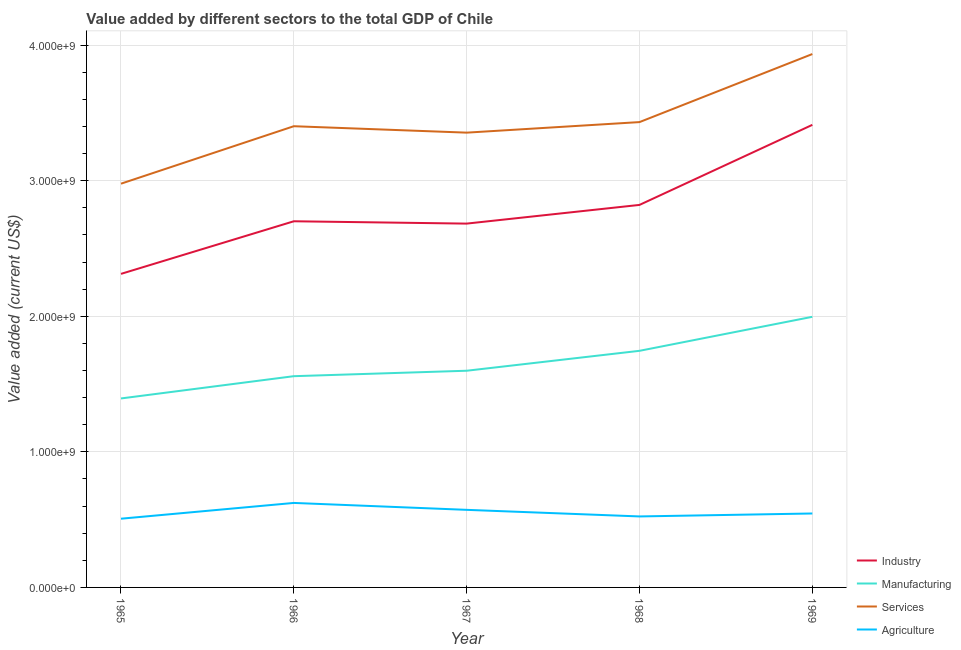What is the value added by agricultural sector in 1968?
Ensure brevity in your answer.  5.24e+08. Across all years, what is the maximum value added by agricultural sector?
Your answer should be compact. 6.23e+08. Across all years, what is the minimum value added by agricultural sector?
Offer a terse response. 5.07e+08. In which year was the value added by services sector maximum?
Offer a terse response. 1969. In which year was the value added by manufacturing sector minimum?
Provide a short and direct response. 1965. What is the total value added by manufacturing sector in the graph?
Provide a short and direct response. 8.29e+09. What is the difference between the value added by services sector in 1967 and that in 1969?
Your answer should be very brief. -5.80e+08. What is the difference between the value added by industrial sector in 1966 and the value added by agricultural sector in 1965?
Ensure brevity in your answer.  2.19e+09. What is the average value added by manufacturing sector per year?
Make the answer very short. 1.66e+09. In the year 1967, what is the difference between the value added by manufacturing sector and value added by agricultural sector?
Provide a short and direct response. 1.03e+09. What is the ratio of the value added by agricultural sector in 1968 to that in 1969?
Your answer should be very brief. 0.96. Is the difference between the value added by agricultural sector in 1965 and 1968 greater than the difference between the value added by industrial sector in 1965 and 1968?
Your response must be concise. Yes. What is the difference between the highest and the second highest value added by manufacturing sector?
Offer a very short reply. 2.51e+08. What is the difference between the highest and the lowest value added by services sector?
Provide a short and direct response. 9.56e+08. In how many years, is the value added by agricultural sector greater than the average value added by agricultural sector taken over all years?
Offer a terse response. 2. Is the sum of the value added by services sector in 1965 and 1967 greater than the maximum value added by agricultural sector across all years?
Give a very brief answer. Yes. Is it the case that in every year, the sum of the value added by industrial sector and value added by manufacturing sector is greater than the value added by services sector?
Your response must be concise. Yes. Does the value added by services sector monotonically increase over the years?
Offer a very short reply. No. How many lines are there?
Your answer should be very brief. 4. How many years are there in the graph?
Give a very brief answer. 5. Are the values on the major ticks of Y-axis written in scientific E-notation?
Your response must be concise. Yes. How are the legend labels stacked?
Give a very brief answer. Vertical. What is the title of the graph?
Ensure brevity in your answer.  Value added by different sectors to the total GDP of Chile. What is the label or title of the Y-axis?
Make the answer very short. Value added (current US$). What is the Value added (current US$) in Industry in 1965?
Your answer should be very brief. 2.31e+09. What is the Value added (current US$) in Manufacturing in 1965?
Offer a terse response. 1.39e+09. What is the Value added (current US$) of Services in 1965?
Provide a succinct answer. 2.98e+09. What is the Value added (current US$) in Agriculture in 1965?
Make the answer very short. 5.07e+08. What is the Value added (current US$) in Industry in 1966?
Offer a very short reply. 2.70e+09. What is the Value added (current US$) of Manufacturing in 1966?
Your answer should be very brief. 1.56e+09. What is the Value added (current US$) of Services in 1966?
Offer a very short reply. 3.40e+09. What is the Value added (current US$) in Agriculture in 1966?
Make the answer very short. 6.23e+08. What is the Value added (current US$) in Industry in 1967?
Make the answer very short. 2.68e+09. What is the Value added (current US$) of Manufacturing in 1967?
Your answer should be very brief. 1.60e+09. What is the Value added (current US$) in Services in 1967?
Keep it short and to the point. 3.35e+09. What is the Value added (current US$) in Agriculture in 1967?
Ensure brevity in your answer.  5.72e+08. What is the Value added (current US$) of Industry in 1968?
Your response must be concise. 2.82e+09. What is the Value added (current US$) of Manufacturing in 1968?
Ensure brevity in your answer.  1.75e+09. What is the Value added (current US$) of Services in 1968?
Your answer should be compact. 3.43e+09. What is the Value added (current US$) in Agriculture in 1968?
Offer a very short reply. 5.24e+08. What is the Value added (current US$) in Industry in 1969?
Ensure brevity in your answer.  3.41e+09. What is the Value added (current US$) of Manufacturing in 1969?
Your answer should be compact. 2.00e+09. What is the Value added (current US$) in Services in 1969?
Provide a short and direct response. 3.93e+09. What is the Value added (current US$) of Agriculture in 1969?
Provide a succinct answer. 5.45e+08. Across all years, what is the maximum Value added (current US$) of Industry?
Give a very brief answer. 3.41e+09. Across all years, what is the maximum Value added (current US$) in Manufacturing?
Offer a terse response. 2.00e+09. Across all years, what is the maximum Value added (current US$) in Services?
Make the answer very short. 3.93e+09. Across all years, what is the maximum Value added (current US$) in Agriculture?
Give a very brief answer. 6.23e+08. Across all years, what is the minimum Value added (current US$) in Industry?
Keep it short and to the point. 2.31e+09. Across all years, what is the minimum Value added (current US$) in Manufacturing?
Make the answer very short. 1.39e+09. Across all years, what is the minimum Value added (current US$) of Services?
Your answer should be compact. 2.98e+09. Across all years, what is the minimum Value added (current US$) of Agriculture?
Your answer should be very brief. 5.07e+08. What is the total Value added (current US$) in Industry in the graph?
Offer a terse response. 1.39e+1. What is the total Value added (current US$) in Manufacturing in the graph?
Your answer should be compact. 8.29e+09. What is the total Value added (current US$) in Services in the graph?
Make the answer very short. 1.71e+1. What is the total Value added (current US$) of Agriculture in the graph?
Keep it short and to the point. 2.77e+09. What is the difference between the Value added (current US$) in Industry in 1965 and that in 1966?
Make the answer very short. -3.88e+08. What is the difference between the Value added (current US$) of Manufacturing in 1965 and that in 1966?
Offer a very short reply. -1.64e+08. What is the difference between the Value added (current US$) of Services in 1965 and that in 1966?
Make the answer very short. -4.24e+08. What is the difference between the Value added (current US$) in Agriculture in 1965 and that in 1966?
Your answer should be compact. -1.16e+08. What is the difference between the Value added (current US$) in Industry in 1965 and that in 1967?
Your response must be concise. -3.71e+08. What is the difference between the Value added (current US$) in Manufacturing in 1965 and that in 1967?
Ensure brevity in your answer.  -2.04e+08. What is the difference between the Value added (current US$) in Services in 1965 and that in 1967?
Make the answer very short. -3.76e+08. What is the difference between the Value added (current US$) in Agriculture in 1965 and that in 1967?
Offer a terse response. -6.53e+07. What is the difference between the Value added (current US$) in Industry in 1965 and that in 1968?
Provide a succinct answer. -5.09e+08. What is the difference between the Value added (current US$) of Manufacturing in 1965 and that in 1968?
Your answer should be very brief. -3.51e+08. What is the difference between the Value added (current US$) of Services in 1965 and that in 1968?
Give a very brief answer. -4.54e+08. What is the difference between the Value added (current US$) in Agriculture in 1965 and that in 1968?
Provide a short and direct response. -1.67e+07. What is the difference between the Value added (current US$) in Industry in 1965 and that in 1969?
Ensure brevity in your answer.  -1.10e+09. What is the difference between the Value added (current US$) of Manufacturing in 1965 and that in 1969?
Provide a short and direct response. -6.02e+08. What is the difference between the Value added (current US$) of Services in 1965 and that in 1969?
Offer a very short reply. -9.56e+08. What is the difference between the Value added (current US$) of Agriculture in 1965 and that in 1969?
Your response must be concise. -3.85e+07. What is the difference between the Value added (current US$) of Industry in 1966 and that in 1967?
Offer a terse response. 1.72e+07. What is the difference between the Value added (current US$) in Manufacturing in 1966 and that in 1967?
Make the answer very short. -4.02e+07. What is the difference between the Value added (current US$) of Services in 1966 and that in 1967?
Ensure brevity in your answer.  4.74e+07. What is the difference between the Value added (current US$) in Agriculture in 1966 and that in 1967?
Give a very brief answer. 5.10e+07. What is the difference between the Value added (current US$) in Industry in 1966 and that in 1968?
Keep it short and to the point. -1.21e+08. What is the difference between the Value added (current US$) of Manufacturing in 1966 and that in 1968?
Provide a short and direct response. -1.87e+08. What is the difference between the Value added (current US$) of Services in 1966 and that in 1968?
Your response must be concise. -3.04e+07. What is the difference between the Value added (current US$) in Agriculture in 1966 and that in 1968?
Offer a terse response. 9.97e+07. What is the difference between the Value added (current US$) in Industry in 1966 and that in 1969?
Your answer should be very brief. -7.11e+08. What is the difference between the Value added (current US$) of Manufacturing in 1966 and that in 1969?
Your answer should be compact. -4.38e+08. What is the difference between the Value added (current US$) in Services in 1966 and that in 1969?
Your answer should be compact. -5.32e+08. What is the difference between the Value added (current US$) in Agriculture in 1966 and that in 1969?
Provide a succinct answer. 7.78e+07. What is the difference between the Value added (current US$) of Industry in 1967 and that in 1968?
Offer a terse response. -1.38e+08. What is the difference between the Value added (current US$) in Manufacturing in 1967 and that in 1968?
Keep it short and to the point. -1.47e+08. What is the difference between the Value added (current US$) in Services in 1967 and that in 1968?
Make the answer very short. -7.78e+07. What is the difference between the Value added (current US$) in Agriculture in 1967 and that in 1968?
Ensure brevity in your answer.  4.87e+07. What is the difference between the Value added (current US$) of Industry in 1967 and that in 1969?
Make the answer very short. -7.28e+08. What is the difference between the Value added (current US$) of Manufacturing in 1967 and that in 1969?
Offer a terse response. -3.98e+08. What is the difference between the Value added (current US$) in Services in 1967 and that in 1969?
Ensure brevity in your answer.  -5.80e+08. What is the difference between the Value added (current US$) of Agriculture in 1967 and that in 1969?
Offer a very short reply. 2.68e+07. What is the difference between the Value added (current US$) in Industry in 1968 and that in 1969?
Your answer should be very brief. -5.90e+08. What is the difference between the Value added (current US$) in Manufacturing in 1968 and that in 1969?
Provide a succinct answer. -2.51e+08. What is the difference between the Value added (current US$) in Services in 1968 and that in 1969?
Your answer should be compact. -5.02e+08. What is the difference between the Value added (current US$) in Agriculture in 1968 and that in 1969?
Your answer should be very brief. -2.19e+07. What is the difference between the Value added (current US$) in Industry in 1965 and the Value added (current US$) in Manufacturing in 1966?
Make the answer very short. 7.55e+08. What is the difference between the Value added (current US$) of Industry in 1965 and the Value added (current US$) of Services in 1966?
Make the answer very short. -1.09e+09. What is the difference between the Value added (current US$) of Industry in 1965 and the Value added (current US$) of Agriculture in 1966?
Ensure brevity in your answer.  1.69e+09. What is the difference between the Value added (current US$) of Manufacturing in 1965 and the Value added (current US$) of Services in 1966?
Offer a very short reply. -2.01e+09. What is the difference between the Value added (current US$) of Manufacturing in 1965 and the Value added (current US$) of Agriculture in 1966?
Offer a terse response. 7.71e+08. What is the difference between the Value added (current US$) of Services in 1965 and the Value added (current US$) of Agriculture in 1966?
Keep it short and to the point. 2.35e+09. What is the difference between the Value added (current US$) of Industry in 1965 and the Value added (current US$) of Manufacturing in 1967?
Provide a succinct answer. 7.14e+08. What is the difference between the Value added (current US$) of Industry in 1965 and the Value added (current US$) of Services in 1967?
Give a very brief answer. -1.04e+09. What is the difference between the Value added (current US$) in Industry in 1965 and the Value added (current US$) in Agriculture in 1967?
Your answer should be very brief. 1.74e+09. What is the difference between the Value added (current US$) of Manufacturing in 1965 and the Value added (current US$) of Services in 1967?
Keep it short and to the point. -1.96e+09. What is the difference between the Value added (current US$) of Manufacturing in 1965 and the Value added (current US$) of Agriculture in 1967?
Ensure brevity in your answer.  8.22e+08. What is the difference between the Value added (current US$) in Services in 1965 and the Value added (current US$) in Agriculture in 1967?
Your answer should be compact. 2.41e+09. What is the difference between the Value added (current US$) in Industry in 1965 and the Value added (current US$) in Manufacturing in 1968?
Your answer should be compact. 5.67e+08. What is the difference between the Value added (current US$) in Industry in 1965 and the Value added (current US$) in Services in 1968?
Provide a short and direct response. -1.12e+09. What is the difference between the Value added (current US$) in Industry in 1965 and the Value added (current US$) in Agriculture in 1968?
Your response must be concise. 1.79e+09. What is the difference between the Value added (current US$) in Manufacturing in 1965 and the Value added (current US$) in Services in 1968?
Offer a terse response. -2.04e+09. What is the difference between the Value added (current US$) in Manufacturing in 1965 and the Value added (current US$) in Agriculture in 1968?
Ensure brevity in your answer.  8.70e+08. What is the difference between the Value added (current US$) of Services in 1965 and the Value added (current US$) of Agriculture in 1968?
Provide a succinct answer. 2.45e+09. What is the difference between the Value added (current US$) of Industry in 1965 and the Value added (current US$) of Manufacturing in 1969?
Make the answer very short. 3.17e+08. What is the difference between the Value added (current US$) of Industry in 1965 and the Value added (current US$) of Services in 1969?
Offer a very short reply. -1.62e+09. What is the difference between the Value added (current US$) in Industry in 1965 and the Value added (current US$) in Agriculture in 1969?
Ensure brevity in your answer.  1.77e+09. What is the difference between the Value added (current US$) in Manufacturing in 1965 and the Value added (current US$) in Services in 1969?
Keep it short and to the point. -2.54e+09. What is the difference between the Value added (current US$) of Manufacturing in 1965 and the Value added (current US$) of Agriculture in 1969?
Provide a short and direct response. 8.48e+08. What is the difference between the Value added (current US$) in Services in 1965 and the Value added (current US$) in Agriculture in 1969?
Ensure brevity in your answer.  2.43e+09. What is the difference between the Value added (current US$) in Industry in 1966 and the Value added (current US$) in Manufacturing in 1967?
Keep it short and to the point. 1.10e+09. What is the difference between the Value added (current US$) of Industry in 1966 and the Value added (current US$) of Services in 1967?
Offer a terse response. -6.54e+08. What is the difference between the Value added (current US$) of Industry in 1966 and the Value added (current US$) of Agriculture in 1967?
Your answer should be very brief. 2.13e+09. What is the difference between the Value added (current US$) in Manufacturing in 1966 and the Value added (current US$) in Services in 1967?
Keep it short and to the point. -1.80e+09. What is the difference between the Value added (current US$) of Manufacturing in 1966 and the Value added (current US$) of Agriculture in 1967?
Provide a short and direct response. 9.86e+08. What is the difference between the Value added (current US$) of Services in 1966 and the Value added (current US$) of Agriculture in 1967?
Your answer should be compact. 2.83e+09. What is the difference between the Value added (current US$) in Industry in 1966 and the Value added (current US$) in Manufacturing in 1968?
Provide a succinct answer. 9.55e+08. What is the difference between the Value added (current US$) in Industry in 1966 and the Value added (current US$) in Services in 1968?
Make the answer very short. -7.31e+08. What is the difference between the Value added (current US$) in Industry in 1966 and the Value added (current US$) in Agriculture in 1968?
Provide a succinct answer. 2.18e+09. What is the difference between the Value added (current US$) of Manufacturing in 1966 and the Value added (current US$) of Services in 1968?
Ensure brevity in your answer.  -1.87e+09. What is the difference between the Value added (current US$) of Manufacturing in 1966 and the Value added (current US$) of Agriculture in 1968?
Offer a very short reply. 1.03e+09. What is the difference between the Value added (current US$) in Services in 1966 and the Value added (current US$) in Agriculture in 1968?
Your answer should be very brief. 2.88e+09. What is the difference between the Value added (current US$) of Industry in 1966 and the Value added (current US$) of Manufacturing in 1969?
Your answer should be compact. 7.05e+08. What is the difference between the Value added (current US$) of Industry in 1966 and the Value added (current US$) of Services in 1969?
Offer a terse response. -1.23e+09. What is the difference between the Value added (current US$) of Industry in 1966 and the Value added (current US$) of Agriculture in 1969?
Provide a short and direct response. 2.16e+09. What is the difference between the Value added (current US$) of Manufacturing in 1966 and the Value added (current US$) of Services in 1969?
Keep it short and to the point. -2.38e+09. What is the difference between the Value added (current US$) in Manufacturing in 1966 and the Value added (current US$) in Agriculture in 1969?
Offer a terse response. 1.01e+09. What is the difference between the Value added (current US$) of Services in 1966 and the Value added (current US$) of Agriculture in 1969?
Ensure brevity in your answer.  2.86e+09. What is the difference between the Value added (current US$) in Industry in 1967 and the Value added (current US$) in Manufacturing in 1968?
Offer a very short reply. 9.38e+08. What is the difference between the Value added (current US$) of Industry in 1967 and the Value added (current US$) of Services in 1968?
Your answer should be very brief. -7.49e+08. What is the difference between the Value added (current US$) of Industry in 1967 and the Value added (current US$) of Agriculture in 1968?
Offer a very short reply. 2.16e+09. What is the difference between the Value added (current US$) of Manufacturing in 1967 and the Value added (current US$) of Services in 1968?
Give a very brief answer. -1.83e+09. What is the difference between the Value added (current US$) of Manufacturing in 1967 and the Value added (current US$) of Agriculture in 1968?
Provide a short and direct response. 1.07e+09. What is the difference between the Value added (current US$) in Services in 1967 and the Value added (current US$) in Agriculture in 1968?
Your response must be concise. 2.83e+09. What is the difference between the Value added (current US$) of Industry in 1967 and the Value added (current US$) of Manufacturing in 1969?
Offer a terse response. 6.87e+08. What is the difference between the Value added (current US$) of Industry in 1967 and the Value added (current US$) of Services in 1969?
Offer a very short reply. -1.25e+09. What is the difference between the Value added (current US$) in Industry in 1967 and the Value added (current US$) in Agriculture in 1969?
Your answer should be compact. 2.14e+09. What is the difference between the Value added (current US$) in Manufacturing in 1967 and the Value added (current US$) in Services in 1969?
Your response must be concise. -2.34e+09. What is the difference between the Value added (current US$) in Manufacturing in 1967 and the Value added (current US$) in Agriculture in 1969?
Your answer should be very brief. 1.05e+09. What is the difference between the Value added (current US$) in Services in 1967 and the Value added (current US$) in Agriculture in 1969?
Your response must be concise. 2.81e+09. What is the difference between the Value added (current US$) in Industry in 1968 and the Value added (current US$) in Manufacturing in 1969?
Your answer should be very brief. 8.25e+08. What is the difference between the Value added (current US$) in Industry in 1968 and the Value added (current US$) in Services in 1969?
Ensure brevity in your answer.  -1.11e+09. What is the difference between the Value added (current US$) in Industry in 1968 and the Value added (current US$) in Agriculture in 1969?
Ensure brevity in your answer.  2.28e+09. What is the difference between the Value added (current US$) in Manufacturing in 1968 and the Value added (current US$) in Services in 1969?
Your answer should be compact. -2.19e+09. What is the difference between the Value added (current US$) in Manufacturing in 1968 and the Value added (current US$) in Agriculture in 1969?
Your answer should be compact. 1.20e+09. What is the difference between the Value added (current US$) of Services in 1968 and the Value added (current US$) of Agriculture in 1969?
Make the answer very short. 2.89e+09. What is the average Value added (current US$) in Industry per year?
Make the answer very short. 2.79e+09. What is the average Value added (current US$) in Manufacturing per year?
Your answer should be compact. 1.66e+09. What is the average Value added (current US$) in Services per year?
Your answer should be compact. 3.42e+09. What is the average Value added (current US$) of Agriculture per year?
Your response must be concise. 5.54e+08. In the year 1965, what is the difference between the Value added (current US$) of Industry and Value added (current US$) of Manufacturing?
Provide a short and direct response. 9.19e+08. In the year 1965, what is the difference between the Value added (current US$) of Industry and Value added (current US$) of Services?
Provide a succinct answer. -6.65e+08. In the year 1965, what is the difference between the Value added (current US$) in Industry and Value added (current US$) in Agriculture?
Your response must be concise. 1.81e+09. In the year 1965, what is the difference between the Value added (current US$) in Manufacturing and Value added (current US$) in Services?
Give a very brief answer. -1.58e+09. In the year 1965, what is the difference between the Value added (current US$) of Manufacturing and Value added (current US$) of Agriculture?
Your response must be concise. 8.87e+08. In the year 1965, what is the difference between the Value added (current US$) of Services and Value added (current US$) of Agriculture?
Provide a succinct answer. 2.47e+09. In the year 1966, what is the difference between the Value added (current US$) in Industry and Value added (current US$) in Manufacturing?
Offer a terse response. 1.14e+09. In the year 1966, what is the difference between the Value added (current US$) of Industry and Value added (current US$) of Services?
Give a very brief answer. -7.01e+08. In the year 1966, what is the difference between the Value added (current US$) in Industry and Value added (current US$) in Agriculture?
Ensure brevity in your answer.  2.08e+09. In the year 1966, what is the difference between the Value added (current US$) in Manufacturing and Value added (current US$) in Services?
Make the answer very short. -1.84e+09. In the year 1966, what is the difference between the Value added (current US$) in Manufacturing and Value added (current US$) in Agriculture?
Give a very brief answer. 9.35e+08. In the year 1966, what is the difference between the Value added (current US$) in Services and Value added (current US$) in Agriculture?
Give a very brief answer. 2.78e+09. In the year 1967, what is the difference between the Value added (current US$) in Industry and Value added (current US$) in Manufacturing?
Your answer should be compact. 1.09e+09. In the year 1967, what is the difference between the Value added (current US$) in Industry and Value added (current US$) in Services?
Your response must be concise. -6.71e+08. In the year 1967, what is the difference between the Value added (current US$) of Industry and Value added (current US$) of Agriculture?
Make the answer very short. 2.11e+09. In the year 1967, what is the difference between the Value added (current US$) in Manufacturing and Value added (current US$) in Services?
Make the answer very short. -1.76e+09. In the year 1967, what is the difference between the Value added (current US$) in Manufacturing and Value added (current US$) in Agriculture?
Your answer should be compact. 1.03e+09. In the year 1967, what is the difference between the Value added (current US$) in Services and Value added (current US$) in Agriculture?
Your answer should be compact. 2.78e+09. In the year 1968, what is the difference between the Value added (current US$) of Industry and Value added (current US$) of Manufacturing?
Provide a short and direct response. 1.08e+09. In the year 1968, what is the difference between the Value added (current US$) in Industry and Value added (current US$) in Services?
Provide a short and direct response. -6.11e+08. In the year 1968, what is the difference between the Value added (current US$) in Industry and Value added (current US$) in Agriculture?
Offer a terse response. 2.30e+09. In the year 1968, what is the difference between the Value added (current US$) in Manufacturing and Value added (current US$) in Services?
Ensure brevity in your answer.  -1.69e+09. In the year 1968, what is the difference between the Value added (current US$) of Manufacturing and Value added (current US$) of Agriculture?
Provide a short and direct response. 1.22e+09. In the year 1968, what is the difference between the Value added (current US$) of Services and Value added (current US$) of Agriculture?
Offer a terse response. 2.91e+09. In the year 1969, what is the difference between the Value added (current US$) in Industry and Value added (current US$) in Manufacturing?
Offer a very short reply. 1.42e+09. In the year 1969, what is the difference between the Value added (current US$) of Industry and Value added (current US$) of Services?
Your response must be concise. -5.22e+08. In the year 1969, what is the difference between the Value added (current US$) of Industry and Value added (current US$) of Agriculture?
Your answer should be compact. 2.87e+09. In the year 1969, what is the difference between the Value added (current US$) of Manufacturing and Value added (current US$) of Services?
Keep it short and to the point. -1.94e+09. In the year 1969, what is the difference between the Value added (current US$) in Manufacturing and Value added (current US$) in Agriculture?
Offer a terse response. 1.45e+09. In the year 1969, what is the difference between the Value added (current US$) in Services and Value added (current US$) in Agriculture?
Your answer should be very brief. 3.39e+09. What is the ratio of the Value added (current US$) in Industry in 1965 to that in 1966?
Make the answer very short. 0.86. What is the ratio of the Value added (current US$) of Manufacturing in 1965 to that in 1966?
Offer a terse response. 0.89. What is the ratio of the Value added (current US$) of Services in 1965 to that in 1966?
Give a very brief answer. 0.88. What is the ratio of the Value added (current US$) of Agriculture in 1965 to that in 1966?
Ensure brevity in your answer.  0.81. What is the ratio of the Value added (current US$) in Industry in 1965 to that in 1967?
Offer a terse response. 0.86. What is the ratio of the Value added (current US$) of Manufacturing in 1965 to that in 1967?
Provide a succinct answer. 0.87. What is the ratio of the Value added (current US$) of Services in 1965 to that in 1967?
Make the answer very short. 0.89. What is the ratio of the Value added (current US$) of Agriculture in 1965 to that in 1967?
Ensure brevity in your answer.  0.89. What is the ratio of the Value added (current US$) of Industry in 1965 to that in 1968?
Make the answer very short. 0.82. What is the ratio of the Value added (current US$) in Manufacturing in 1965 to that in 1968?
Make the answer very short. 0.8. What is the ratio of the Value added (current US$) of Services in 1965 to that in 1968?
Your answer should be very brief. 0.87. What is the ratio of the Value added (current US$) of Agriculture in 1965 to that in 1968?
Provide a short and direct response. 0.97. What is the ratio of the Value added (current US$) in Industry in 1965 to that in 1969?
Offer a terse response. 0.68. What is the ratio of the Value added (current US$) in Manufacturing in 1965 to that in 1969?
Keep it short and to the point. 0.7. What is the ratio of the Value added (current US$) of Services in 1965 to that in 1969?
Your response must be concise. 0.76. What is the ratio of the Value added (current US$) of Agriculture in 1965 to that in 1969?
Offer a very short reply. 0.93. What is the ratio of the Value added (current US$) of Industry in 1966 to that in 1967?
Ensure brevity in your answer.  1.01. What is the ratio of the Value added (current US$) of Manufacturing in 1966 to that in 1967?
Make the answer very short. 0.97. What is the ratio of the Value added (current US$) of Services in 1966 to that in 1967?
Provide a succinct answer. 1.01. What is the ratio of the Value added (current US$) in Agriculture in 1966 to that in 1967?
Your response must be concise. 1.09. What is the ratio of the Value added (current US$) in Industry in 1966 to that in 1968?
Give a very brief answer. 0.96. What is the ratio of the Value added (current US$) in Manufacturing in 1966 to that in 1968?
Provide a succinct answer. 0.89. What is the ratio of the Value added (current US$) in Agriculture in 1966 to that in 1968?
Provide a succinct answer. 1.19. What is the ratio of the Value added (current US$) in Industry in 1966 to that in 1969?
Your answer should be compact. 0.79. What is the ratio of the Value added (current US$) in Manufacturing in 1966 to that in 1969?
Offer a terse response. 0.78. What is the ratio of the Value added (current US$) of Services in 1966 to that in 1969?
Provide a succinct answer. 0.86. What is the ratio of the Value added (current US$) of Agriculture in 1966 to that in 1969?
Keep it short and to the point. 1.14. What is the ratio of the Value added (current US$) of Industry in 1967 to that in 1968?
Your response must be concise. 0.95. What is the ratio of the Value added (current US$) in Manufacturing in 1967 to that in 1968?
Your response must be concise. 0.92. What is the ratio of the Value added (current US$) in Services in 1967 to that in 1968?
Ensure brevity in your answer.  0.98. What is the ratio of the Value added (current US$) of Agriculture in 1967 to that in 1968?
Make the answer very short. 1.09. What is the ratio of the Value added (current US$) in Industry in 1967 to that in 1969?
Provide a succinct answer. 0.79. What is the ratio of the Value added (current US$) in Manufacturing in 1967 to that in 1969?
Provide a short and direct response. 0.8. What is the ratio of the Value added (current US$) in Services in 1967 to that in 1969?
Your answer should be very brief. 0.85. What is the ratio of the Value added (current US$) in Agriculture in 1967 to that in 1969?
Ensure brevity in your answer.  1.05. What is the ratio of the Value added (current US$) of Industry in 1968 to that in 1969?
Your answer should be very brief. 0.83. What is the ratio of the Value added (current US$) of Manufacturing in 1968 to that in 1969?
Offer a terse response. 0.87. What is the ratio of the Value added (current US$) in Services in 1968 to that in 1969?
Make the answer very short. 0.87. What is the ratio of the Value added (current US$) in Agriculture in 1968 to that in 1969?
Your answer should be very brief. 0.96. What is the difference between the highest and the second highest Value added (current US$) of Industry?
Offer a very short reply. 5.90e+08. What is the difference between the highest and the second highest Value added (current US$) of Manufacturing?
Offer a very short reply. 2.51e+08. What is the difference between the highest and the second highest Value added (current US$) of Services?
Your answer should be very brief. 5.02e+08. What is the difference between the highest and the second highest Value added (current US$) in Agriculture?
Give a very brief answer. 5.10e+07. What is the difference between the highest and the lowest Value added (current US$) of Industry?
Your answer should be compact. 1.10e+09. What is the difference between the highest and the lowest Value added (current US$) in Manufacturing?
Your response must be concise. 6.02e+08. What is the difference between the highest and the lowest Value added (current US$) of Services?
Your answer should be compact. 9.56e+08. What is the difference between the highest and the lowest Value added (current US$) of Agriculture?
Your response must be concise. 1.16e+08. 